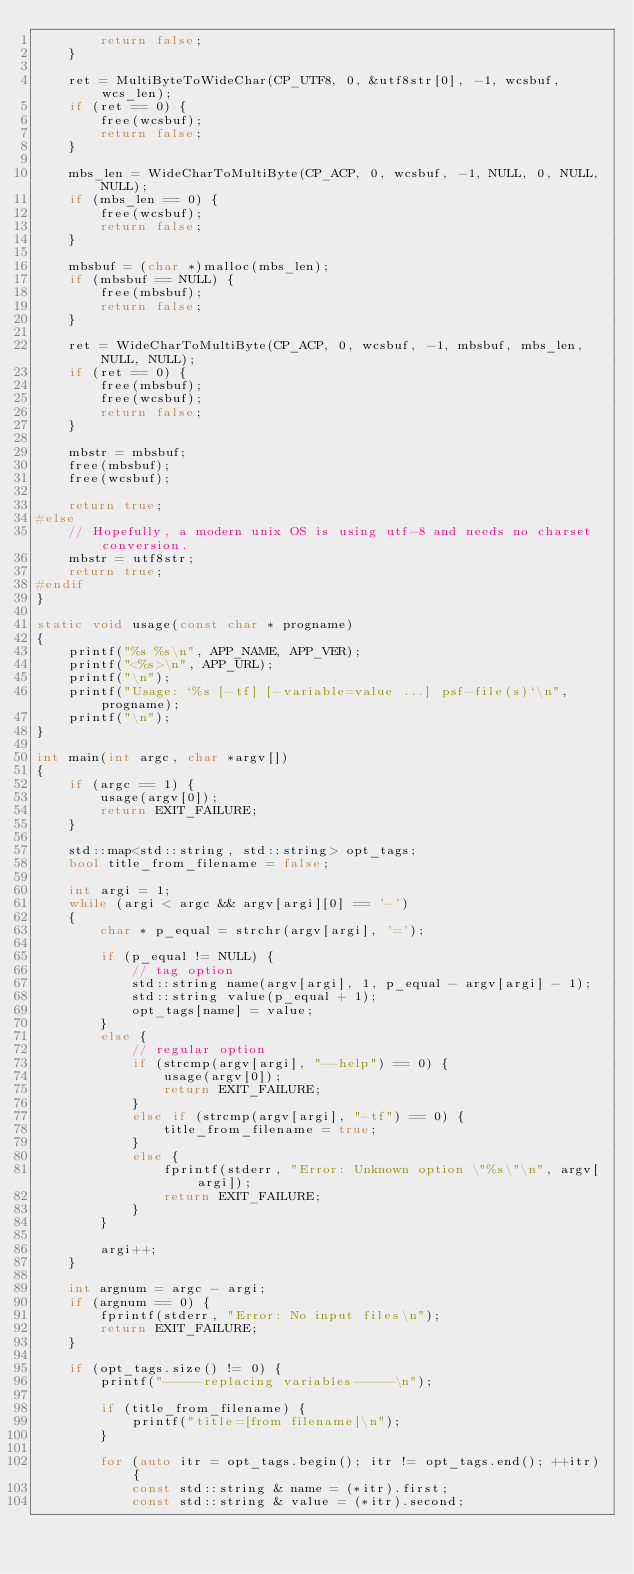Convert code to text. <code><loc_0><loc_0><loc_500><loc_500><_C++_>		return false;
	}

	ret = MultiByteToWideChar(CP_UTF8, 0, &utf8str[0], -1, wcsbuf, wcs_len);
	if (ret == 0) {
		free(wcsbuf);
		return false;
	}

	mbs_len = WideCharToMultiByte(CP_ACP, 0, wcsbuf, -1, NULL, 0, NULL, NULL);
	if (mbs_len == 0) {
		free(wcsbuf);
		return false;
	}

	mbsbuf = (char *)malloc(mbs_len);
	if (mbsbuf == NULL) {
		free(mbsbuf);
		return false;
	}

	ret = WideCharToMultiByte(CP_ACP, 0, wcsbuf, -1, mbsbuf, mbs_len, NULL, NULL);
	if (ret == 0) {
		free(mbsbuf);
		free(wcsbuf);
		return false;
	}

	mbstr = mbsbuf;
	free(mbsbuf);
	free(wcsbuf);

	return true;
#else
	// Hopefully, a modern unix OS is using utf-8 and needs no charset conversion.
	mbstr = utf8str;
	return true;
#endif
}

static void usage(const char * progname)
{
	printf("%s %s\n", APP_NAME, APP_VER);
	printf("<%s>\n", APP_URL);
	printf("\n");
	printf("Usage: `%s [-tf] [-variable=value ...] psf-file(s)`\n", progname);
	printf("\n");
}

int main(int argc, char *argv[])
{
	if (argc == 1) {
		usage(argv[0]);
		return EXIT_FAILURE;
	}

	std::map<std::string, std::string> opt_tags;
	bool title_from_filename = false;

	int argi = 1;
	while (argi < argc && argv[argi][0] == '-')
	{
		char * p_equal = strchr(argv[argi], '=');

		if (p_equal != NULL) {
			// tag option
			std::string name(argv[argi], 1, p_equal - argv[argi] - 1);
			std::string value(p_equal + 1);
			opt_tags[name] = value;
		}
		else {
			// regular option
			if (strcmp(argv[argi], "--help") == 0) {
				usage(argv[0]);
				return EXIT_FAILURE;
			}
			else if (strcmp(argv[argi], "-tf") == 0) {
				title_from_filename = true;
			}
			else {
				fprintf(stderr, "Error: Unknown option \"%s\"\n", argv[argi]);
				return EXIT_FAILURE;
			}
		}

		argi++;
	}

	int argnum = argc - argi;
	if (argnum == 0) {
		fprintf(stderr, "Error: No input files\n");
		return EXIT_FAILURE;
	}

	if (opt_tags.size() != 0) {
		printf("-----replacing variables-----\n");

		if (title_from_filename) {
			printf("title=[from filename]\n");
		}

		for (auto itr = opt_tags.begin(); itr != opt_tags.end(); ++itr) {
			const std::string & name = (*itr).first;
			const std::string & value = (*itr).second;
</code> 